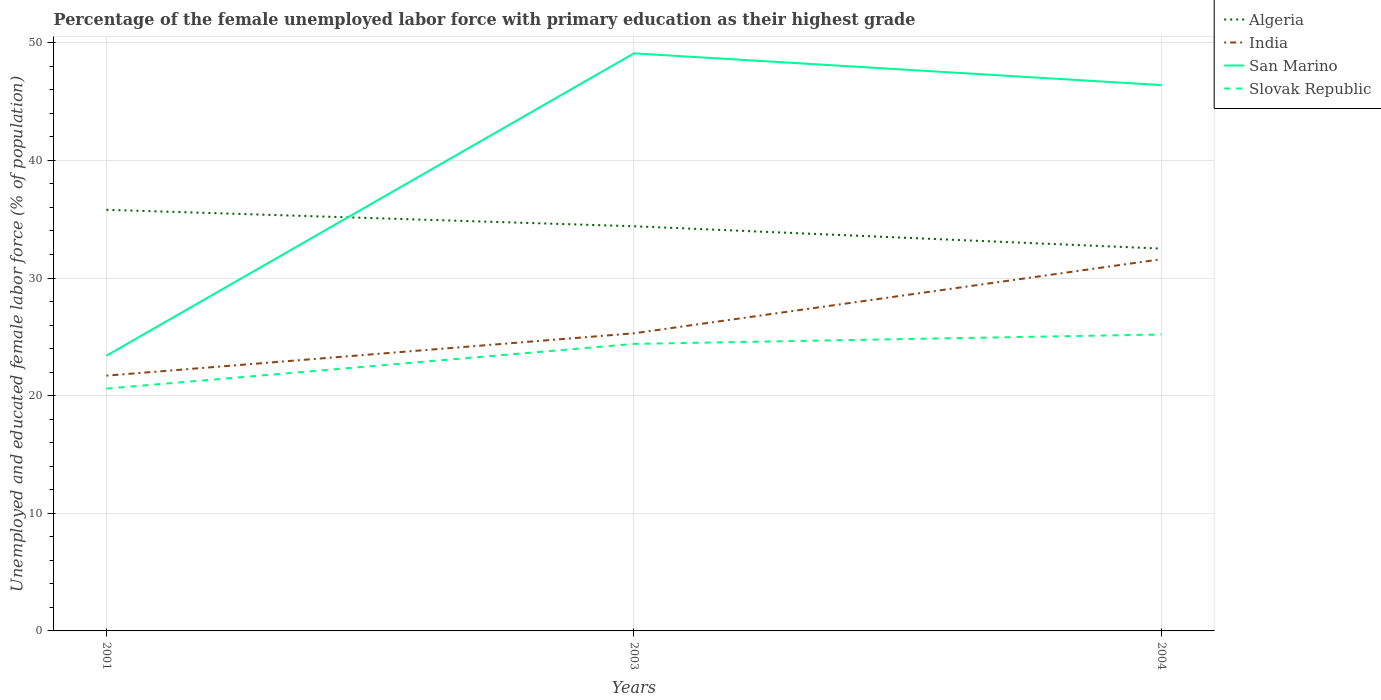How many different coloured lines are there?
Give a very brief answer. 4. Does the line corresponding to San Marino intersect with the line corresponding to Algeria?
Offer a terse response. Yes. Across all years, what is the maximum percentage of the unemployed female labor force with primary education in India?
Your response must be concise. 21.7. What is the total percentage of the unemployed female labor force with primary education in San Marino in the graph?
Offer a very short reply. -25.7. What is the difference between the highest and the second highest percentage of the unemployed female labor force with primary education in India?
Make the answer very short. 9.9. What is the difference between the highest and the lowest percentage of the unemployed female labor force with primary education in India?
Provide a short and direct response. 1. Is the percentage of the unemployed female labor force with primary education in San Marino strictly greater than the percentage of the unemployed female labor force with primary education in Algeria over the years?
Your answer should be very brief. No. How many lines are there?
Your answer should be very brief. 4. Does the graph contain grids?
Provide a short and direct response. Yes. How many legend labels are there?
Offer a terse response. 4. How are the legend labels stacked?
Keep it short and to the point. Vertical. What is the title of the graph?
Give a very brief answer. Percentage of the female unemployed labor force with primary education as their highest grade. What is the label or title of the X-axis?
Offer a terse response. Years. What is the label or title of the Y-axis?
Your answer should be very brief. Unemployed and educated female labor force (% of population). What is the Unemployed and educated female labor force (% of population) of Algeria in 2001?
Offer a terse response. 35.8. What is the Unemployed and educated female labor force (% of population) in India in 2001?
Your answer should be compact. 21.7. What is the Unemployed and educated female labor force (% of population) in San Marino in 2001?
Ensure brevity in your answer.  23.4. What is the Unemployed and educated female labor force (% of population) of Slovak Republic in 2001?
Provide a succinct answer. 20.6. What is the Unemployed and educated female labor force (% of population) in Algeria in 2003?
Keep it short and to the point. 34.4. What is the Unemployed and educated female labor force (% of population) in India in 2003?
Make the answer very short. 25.3. What is the Unemployed and educated female labor force (% of population) in San Marino in 2003?
Your answer should be compact. 49.1. What is the Unemployed and educated female labor force (% of population) in Slovak Republic in 2003?
Offer a very short reply. 24.4. What is the Unemployed and educated female labor force (% of population) of Algeria in 2004?
Keep it short and to the point. 32.5. What is the Unemployed and educated female labor force (% of population) in India in 2004?
Provide a succinct answer. 31.6. What is the Unemployed and educated female labor force (% of population) in San Marino in 2004?
Provide a succinct answer. 46.4. What is the Unemployed and educated female labor force (% of population) of Slovak Republic in 2004?
Ensure brevity in your answer.  25.2. Across all years, what is the maximum Unemployed and educated female labor force (% of population) in Algeria?
Your response must be concise. 35.8. Across all years, what is the maximum Unemployed and educated female labor force (% of population) in India?
Make the answer very short. 31.6. Across all years, what is the maximum Unemployed and educated female labor force (% of population) in San Marino?
Keep it short and to the point. 49.1. Across all years, what is the maximum Unemployed and educated female labor force (% of population) of Slovak Republic?
Ensure brevity in your answer.  25.2. Across all years, what is the minimum Unemployed and educated female labor force (% of population) in Algeria?
Provide a short and direct response. 32.5. Across all years, what is the minimum Unemployed and educated female labor force (% of population) of India?
Make the answer very short. 21.7. Across all years, what is the minimum Unemployed and educated female labor force (% of population) in San Marino?
Your answer should be compact. 23.4. Across all years, what is the minimum Unemployed and educated female labor force (% of population) of Slovak Republic?
Offer a very short reply. 20.6. What is the total Unemployed and educated female labor force (% of population) of Algeria in the graph?
Provide a succinct answer. 102.7. What is the total Unemployed and educated female labor force (% of population) of India in the graph?
Make the answer very short. 78.6. What is the total Unemployed and educated female labor force (% of population) of San Marino in the graph?
Offer a terse response. 118.9. What is the total Unemployed and educated female labor force (% of population) of Slovak Republic in the graph?
Give a very brief answer. 70.2. What is the difference between the Unemployed and educated female labor force (% of population) of Algeria in 2001 and that in 2003?
Make the answer very short. 1.4. What is the difference between the Unemployed and educated female labor force (% of population) of San Marino in 2001 and that in 2003?
Offer a very short reply. -25.7. What is the difference between the Unemployed and educated female labor force (% of population) in Slovak Republic in 2001 and that in 2003?
Provide a succinct answer. -3.8. What is the difference between the Unemployed and educated female labor force (% of population) of India in 2001 and that in 2004?
Provide a short and direct response. -9.9. What is the difference between the Unemployed and educated female labor force (% of population) in Slovak Republic in 2001 and that in 2004?
Give a very brief answer. -4.6. What is the difference between the Unemployed and educated female labor force (% of population) of Algeria in 2003 and that in 2004?
Keep it short and to the point. 1.9. What is the difference between the Unemployed and educated female labor force (% of population) in India in 2003 and that in 2004?
Your answer should be very brief. -6.3. What is the difference between the Unemployed and educated female labor force (% of population) of Slovak Republic in 2003 and that in 2004?
Give a very brief answer. -0.8. What is the difference between the Unemployed and educated female labor force (% of population) of India in 2001 and the Unemployed and educated female labor force (% of population) of San Marino in 2003?
Provide a short and direct response. -27.4. What is the difference between the Unemployed and educated female labor force (% of population) of San Marino in 2001 and the Unemployed and educated female labor force (% of population) of Slovak Republic in 2003?
Your response must be concise. -1. What is the difference between the Unemployed and educated female labor force (% of population) in Algeria in 2001 and the Unemployed and educated female labor force (% of population) in India in 2004?
Your answer should be compact. 4.2. What is the difference between the Unemployed and educated female labor force (% of population) of Algeria in 2001 and the Unemployed and educated female labor force (% of population) of San Marino in 2004?
Keep it short and to the point. -10.6. What is the difference between the Unemployed and educated female labor force (% of population) in Algeria in 2001 and the Unemployed and educated female labor force (% of population) in Slovak Republic in 2004?
Give a very brief answer. 10.6. What is the difference between the Unemployed and educated female labor force (% of population) in India in 2001 and the Unemployed and educated female labor force (% of population) in San Marino in 2004?
Provide a succinct answer. -24.7. What is the difference between the Unemployed and educated female labor force (% of population) in India in 2001 and the Unemployed and educated female labor force (% of population) in Slovak Republic in 2004?
Keep it short and to the point. -3.5. What is the difference between the Unemployed and educated female labor force (% of population) of San Marino in 2001 and the Unemployed and educated female labor force (% of population) of Slovak Republic in 2004?
Provide a short and direct response. -1.8. What is the difference between the Unemployed and educated female labor force (% of population) of Algeria in 2003 and the Unemployed and educated female labor force (% of population) of India in 2004?
Make the answer very short. 2.8. What is the difference between the Unemployed and educated female labor force (% of population) in Algeria in 2003 and the Unemployed and educated female labor force (% of population) in San Marino in 2004?
Your response must be concise. -12. What is the difference between the Unemployed and educated female labor force (% of population) of Algeria in 2003 and the Unemployed and educated female labor force (% of population) of Slovak Republic in 2004?
Ensure brevity in your answer.  9.2. What is the difference between the Unemployed and educated female labor force (% of population) of India in 2003 and the Unemployed and educated female labor force (% of population) of San Marino in 2004?
Ensure brevity in your answer.  -21.1. What is the difference between the Unemployed and educated female labor force (% of population) of India in 2003 and the Unemployed and educated female labor force (% of population) of Slovak Republic in 2004?
Offer a terse response. 0.1. What is the difference between the Unemployed and educated female labor force (% of population) of San Marino in 2003 and the Unemployed and educated female labor force (% of population) of Slovak Republic in 2004?
Make the answer very short. 23.9. What is the average Unemployed and educated female labor force (% of population) in Algeria per year?
Provide a succinct answer. 34.23. What is the average Unemployed and educated female labor force (% of population) in India per year?
Your response must be concise. 26.2. What is the average Unemployed and educated female labor force (% of population) in San Marino per year?
Ensure brevity in your answer.  39.63. What is the average Unemployed and educated female labor force (% of population) in Slovak Republic per year?
Make the answer very short. 23.4. In the year 2003, what is the difference between the Unemployed and educated female labor force (% of population) in Algeria and Unemployed and educated female labor force (% of population) in India?
Offer a very short reply. 9.1. In the year 2003, what is the difference between the Unemployed and educated female labor force (% of population) in Algeria and Unemployed and educated female labor force (% of population) in San Marino?
Offer a terse response. -14.7. In the year 2003, what is the difference between the Unemployed and educated female labor force (% of population) of Algeria and Unemployed and educated female labor force (% of population) of Slovak Republic?
Provide a short and direct response. 10. In the year 2003, what is the difference between the Unemployed and educated female labor force (% of population) in India and Unemployed and educated female labor force (% of population) in San Marino?
Keep it short and to the point. -23.8. In the year 2003, what is the difference between the Unemployed and educated female labor force (% of population) of San Marino and Unemployed and educated female labor force (% of population) of Slovak Republic?
Make the answer very short. 24.7. In the year 2004, what is the difference between the Unemployed and educated female labor force (% of population) in Algeria and Unemployed and educated female labor force (% of population) in San Marino?
Make the answer very short. -13.9. In the year 2004, what is the difference between the Unemployed and educated female labor force (% of population) of Algeria and Unemployed and educated female labor force (% of population) of Slovak Republic?
Offer a very short reply. 7.3. In the year 2004, what is the difference between the Unemployed and educated female labor force (% of population) in India and Unemployed and educated female labor force (% of population) in San Marino?
Your answer should be compact. -14.8. In the year 2004, what is the difference between the Unemployed and educated female labor force (% of population) of India and Unemployed and educated female labor force (% of population) of Slovak Republic?
Give a very brief answer. 6.4. In the year 2004, what is the difference between the Unemployed and educated female labor force (% of population) of San Marino and Unemployed and educated female labor force (% of population) of Slovak Republic?
Provide a short and direct response. 21.2. What is the ratio of the Unemployed and educated female labor force (% of population) in Algeria in 2001 to that in 2003?
Provide a short and direct response. 1.04. What is the ratio of the Unemployed and educated female labor force (% of population) in India in 2001 to that in 2003?
Your answer should be very brief. 0.86. What is the ratio of the Unemployed and educated female labor force (% of population) of San Marino in 2001 to that in 2003?
Provide a short and direct response. 0.48. What is the ratio of the Unemployed and educated female labor force (% of population) of Slovak Republic in 2001 to that in 2003?
Your answer should be compact. 0.84. What is the ratio of the Unemployed and educated female labor force (% of population) of Algeria in 2001 to that in 2004?
Ensure brevity in your answer.  1.1. What is the ratio of the Unemployed and educated female labor force (% of population) in India in 2001 to that in 2004?
Make the answer very short. 0.69. What is the ratio of the Unemployed and educated female labor force (% of population) of San Marino in 2001 to that in 2004?
Make the answer very short. 0.5. What is the ratio of the Unemployed and educated female labor force (% of population) in Slovak Republic in 2001 to that in 2004?
Offer a terse response. 0.82. What is the ratio of the Unemployed and educated female labor force (% of population) in Algeria in 2003 to that in 2004?
Provide a succinct answer. 1.06. What is the ratio of the Unemployed and educated female labor force (% of population) of India in 2003 to that in 2004?
Provide a short and direct response. 0.8. What is the ratio of the Unemployed and educated female labor force (% of population) of San Marino in 2003 to that in 2004?
Provide a short and direct response. 1.06. What is the ratio of the Unemployed and educated female labor force (% of population) of Slovak Republic in 2003 to that in 2004?
Ensure brevity in your answer.  0.97. What is the difference between the highest and the second highest Unemployed and educated female labor force (% of population) in Algeria?
Provide a short and direct response. 1.4. What is the difference between the highest and the second highest Unemployed and educated female labor force (% of population) of India?
Provide a succinct answer. 6.3. What is the difference between the highest and the second highest Unemployed and educated female labor force (% of population) in Slovak Republic?
Provide a succinct answer. 0.8. What is the difference between the highest and the lowest Unemployed and educated female labor force (% of population) in Algeria?
Ensure brevity in your answer.  3.3. What is the difference between the highest and the lowest Unemployed and educated female labor force (% of population) of India?
Offer a terse response. 9.9. What is the difference between the highest and the lowest Unemployed and educated female labor force (% of population) of San Marino?
Provide a succinct answer. 25.7. What is the difference between the highest and the lowest Unemployed and educated female labor force (% of population) in Slovak Republic?
Offer a very short reply. 4.6. 